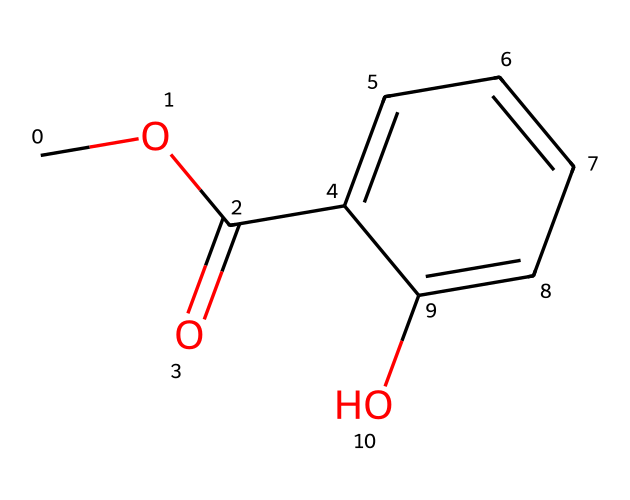What is the molecular formula of methyl salicylate? To find the molecular formula, we count the number of each type of atom in the structure represented by the SMILES code. There are 9 carbon (C) atoms, 10 hydrogen (H) atoms, and 4 oxygen (O) atoms. Therefore, the molecular formula is C9H10O4.
Answer: C9H10O4 How many oxygen atoms are present? By examining the SMILES representation, we can see that there are 4 instances of 'O', indicating there are 4 oxygen atoms in the structure.
Answer: 4 What type of functional groups are present in methyl salicylate? Analyzing the structure, we identify two functional groups: the ester group (–COO–) and a hydroxyl group (–OH). This indicates that the molecule possesses both ester and alcohol characteristics.
Answer: ester, alcohol What is the primary feature that classifies this compound as an ester? The primary structural feature that classifies this compound as an ester is the presence of the carbonyl group (C=O) adjacent to an ether-like group (–O–). This specific arrangement defines esters.
Answer: carbonyl next to oxygen How many rings are in the molecular structure of methyl salicylate? We examine the structure represented in the SMILES. There is one cyclic part indicated by "C1=CC=CC=C1", which shows a six-membered carbon ring. So, there is one ring present.
Answer: 1 What is the relationship between methyl salicylate and pain relief? Methyl salicylate is known for its analgesic properties, which means it can relieve pain through its action as a topical treatment. This is a key reason for its presence in pain-relieving products.
Answer: analgesic properties 